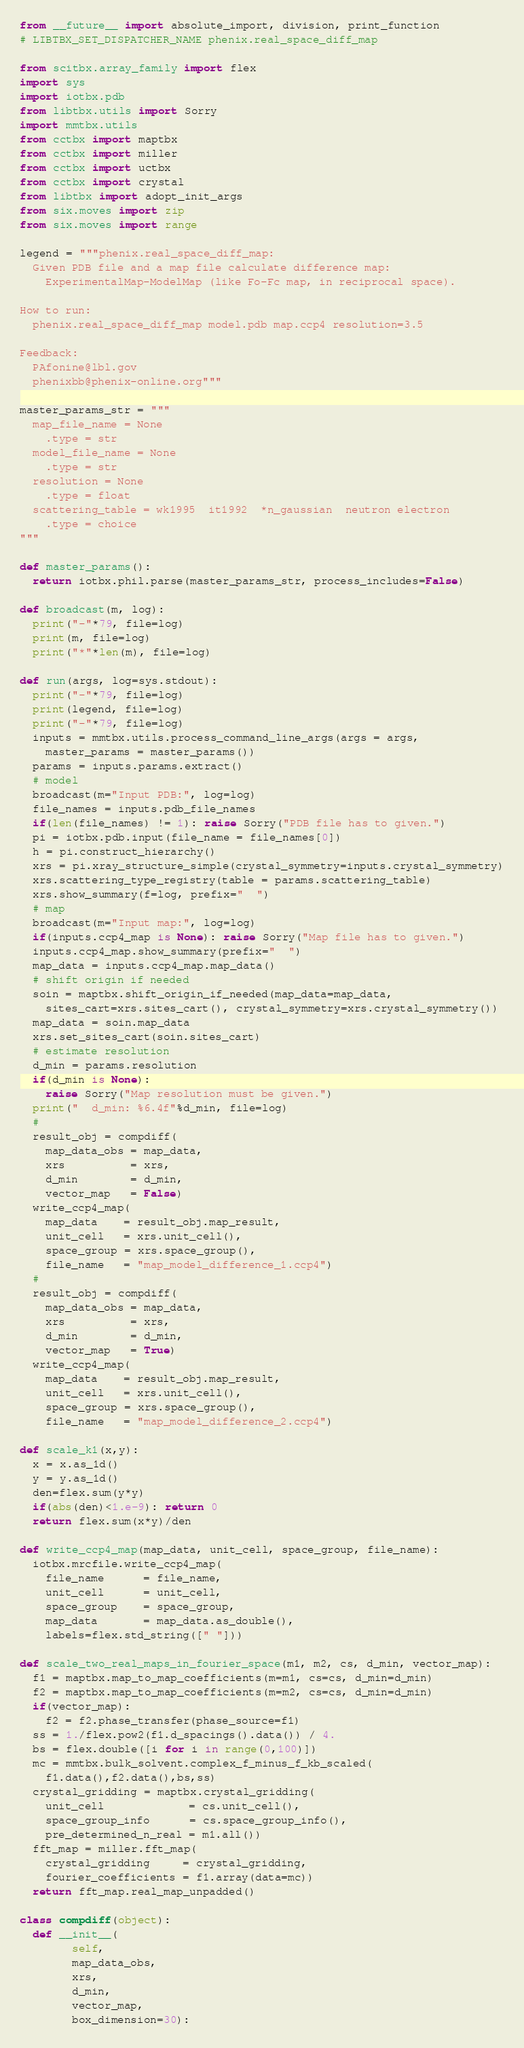<code> <loc_0><loc_0><loc_500><loc_500><_Python_>from __future__ import absolute_import, division, print_function
# LIBTBX_SET_DISPATCHER_NAME phenix.real_space_diff_map

from scitbx.array_family import flex
import sys
import iotbx.pdb
from libtbx.utils import Sorry
import mmtbx.utils
from cctbx import maptbx
from cctbx import miller
from cctbx import uctbx
from cctbx import crystal
from libtbx import adopt_init_args
from six.moves import zip
from six.moves import range

legend = """phenix.real_space_diff_map:
  Given PDB file and a map file calculate difference map:
    ExperimentalMap-ModelMap (like Fo-Fc map, in reciprocal space).

How to run:
  phenix.real_space_diff_map model.pdb map.ccp4 resolution=3.5

Feedback:
  PAfonine@lbl.gov
  phenixbb@phenix-online.org"""

master_params_str = """
  map_file_name = None
    .type = str
  model_file_name = None
    .type = str
  resolution = None
    .type = float
  scattering_table = wk1995  it1992  *n_gaussian  neutron electron
    .type = choice
"""

def master_params():
  return iotbx.phil.parse(master_params_str, process_includes=False)

def broadcast(m, log):
  print("-"*79, file=log)
  print(m, file=log)
  print("*"*len(m), file=log)

def run(args, log=sys.stdout):
  print("-"*79, file=log)
  print(legend, file=log)
  print("-"*79, file=log)
  inputs = mmtbx.utils.process_command_line_args(args = args,
    master_params = master_params())
  params = inputs.params.extract()
  # model
  broadcast(m="Input PDB:", log=log)
  file_names = inputs.pdb_file_names
  if(len(file_names) != 1): raise Sorry("PDB file has to given.")
  pi = iotbx.pdb.input(file_name = file_names[0])
  h = pi.construct_hierarchy()
  xrs = pi.xray_structure_simple(crystal_symmetry=inputs.crystal_symmetry)
  xrs.scattering_type_registry(table = params.scattering_table)
  xrs.show_summary(f=log, prefix="  ")
  # map
  broadcast(m="Input map:", log=log)
  if(inputs.ccp4_map is None): raise Sorry("Map file has to given.")
  inputs.ccp4_map.show_summary(prefix="  ")
  map_data = inputs.ccp4_map.map_data()
  # shift origin if needed
  soin = maptbx.shift_origin_if_needed(map_data=map_data,
    sites_cart=xrs.sites_cart(), crystal_symmetry=xrs.crystal_symmetry())
  map_data = soin.map_data
  xrs.set_sites_cart(soin.sites_cart)
  # estimate resolution
  d_min = params.resolution
  if(d_min is None):
    raise Sorry("Map resolution must be given.")
  print("  d_min: %6.4f"%d_min, file=log)
  #
  result_obj = compdiff(
    map_data_obs = map_data,
    xrs          = xrs,
    d_min        = d_min,
    vector_map   = False)
  write_ccp4_map(
    map_data    = result_obj.map_result,
    unit_cell   = xrs.unit_cell(),
    space_group = xrs.space_group(),
    file_name   = "map_model_difference_1.ccp4")
  #
  result_obj = compdiff(
    map_data_obs = map_data,
    xrs          = xrs,
    d_min        = d_min,
    vector_map   = True)
  write_ccp4_map(
    map_data    = result_obj.map_result,
    unit_cell   = xrs.unit_cell(),
    space_group = xrs.space_group(),
    file_name   = "map_model_difference_2.ccp4")

def scale_k1(x,y):
  x = x.as_1d()
  y = y.as_1d()
  den=flex.sum(y*y)
  if(abs(den)<1.e-9): return 0
  return flex.sum(x*y)/den

def write_ccp4_map(map_data, unit_cell, space_group, file_name):
  iotbx.mrcfile.write_ccp4_map(
    file_name      = file_name,
    unit_cell      = unit_cell,
    space_group    = space_group,
    map_data       = map_data.as_double(),
    labels=flex.std_string([" "]))

def scale_two_real_maps_in_fourier_space(m1, m2, cs, d_min, vector_map):
  f1 = maptbx.map_to_map_coefficients(m=m1, cs=cs, d_min=d_min)
  f2 = maptbx.map_to_map_coefficients(m=m2, cs=cs, d_min=d_min)
  if(vector_map):
    f2 = f2.phase_transfer(phase_source=f1)
  ss = 1./flex.pow2(f1.d_spacings().data()) / 4.
  bs = flex.double([i for i in range(0,100)])
  mc = mmtbx.bulk_solvent.complex_f_minus_f_kb_scaled(
    f1.data(),f2.data(),bs,ss)
  crystal_gridding = maptbx.crystal_gridding(
    unit_cell             = cs.unit_cell(),
    space_group_info      = cs.space_group_info(),
    pre_determined_n_real = m1.all())
  fft_map = miller.fft_map(
    crystal_gridding     = crystal_gridding,
    fourier_coefficients = f1.array(data=mc))
  return fft_map.real_map_unpadded()

class compdiff(object):
  def __init__(
        self,
        map_data_obs,
        xrs,
        d_min,
        vector_map,
        box_dimension=30):</code> 